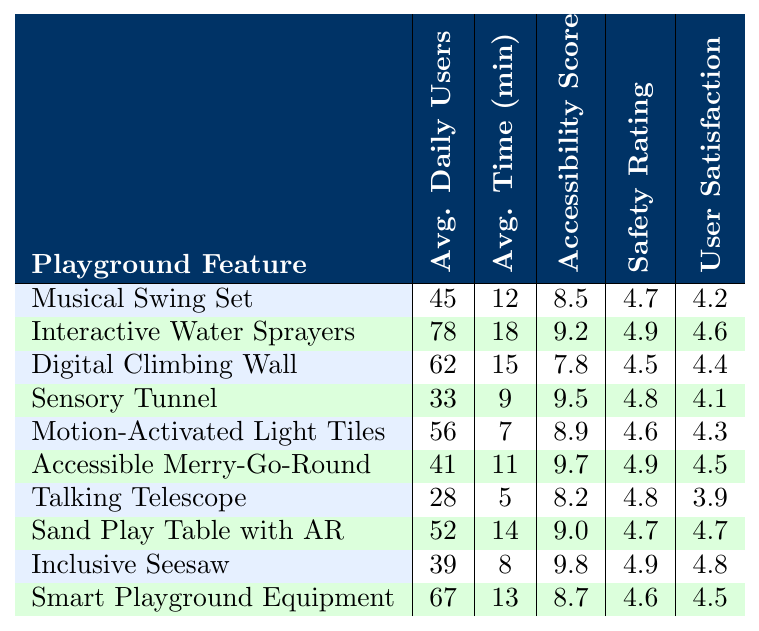What is the accessibility score of the Interactive Water Sprayers? The table shows that the accessibility score for the Interactive Water Sprayers is listed as 9.2.
Answer: 9.2 Which playground feature has the highest average daily users? By looking at the average daily users column, the Interactive Water Sprayers has the highest number at 78.
Answer: Interactive Water Sprayers What is the average time spent on the Sensory Tunnel? The table indicates that the average time spent on the Sensory Tunnel is 9 minutes.
Answer: 9 minutes Is the user satisfaction score for the Accessible Merry-Go-Round higher than that of the Talking Telescope? The user satisfaction score for the Accessible Merry-Go-Round is 4.5 and for the Talking Telescope is 3.9. Since 4.5 is greater than 3.9, the answer is yes.
Answer: Yes What is the difference in average daily users between the Digital Climbing Wall and the Accessible Merry-Go-Round? The average daily users for the Digital Climbing Wall is 62, and for the Accessible Merry-Go-Round is 41. The difference is calculated as 62 - 41 = 21.
Answer: 21 Which playground feature has both the highest accessibility score and user satisfaction score? Reviewing the table, the Inclusive Seesaw has the highest accessibility score of 9.8 and a user satisfaction score of 4.8, which are the highest for both categories.
Answer: Inclusive Seesaw Calculate the average user satisfaction score of all playground features. To find the average, we sum the user satisfaction scores (4.2 + 4.6 + 4.4 + 4.1 + 4.3 + 4.5 + 3.9 + 4.7 + 4.8 + 4.5 = 44.0), then divide by the number of features, which is 10. So, 44.0 / 10 = 4.4.
Answer: 4.4 Are there any playground features with a user satisfaction score below 4.0? In the user satisfaction score column, the Talking Telescope has a score of 3.9, which is below 4.0. Thus, the answer is yes.
Answer: Yes What is the average time spent on features that have an accessibility score greater than 9.0? The features with an accessibility score greater than 9.0 are the Interactive Water Sprayers (18 min), Sensory Tunnel (9 min), Accessible Merry-Go-Round (11 min), Sand Play Table with AR (14 min), and Inclusive Seesaw (8 min). The average is (18 + 9 + 11 + 14 + 8) / 5 = 12.
Answer: 12 minutes Identify a feature that has a safety rating lower than the average safety rating of all features. The average safety rating can be calculated as (4.7 + 4.9 + 4.5 + 4.8 + 4.6 + 4.9 + 4.8 + 4.7 + 4.9 + 4.6) / 10 = 4.7. The Digital Climbing Wall has a safety rating of 4.5, which is lower than the average, so this is a potential answer.
Answer: Digital Climbing Wall 